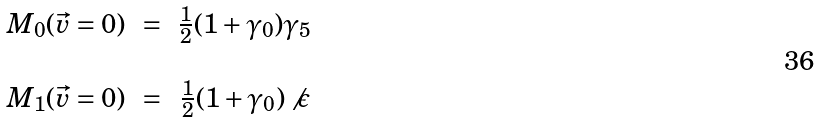<formula> <loc_0><loc_0><loc_500><loc_500>\begin{array} { c c c } M _ { 0 } ( \vec { v } = 0 ) & = & \frac { 1 } { 2 } ( 1 + \gamma _ { 0 } ) \gamma _ { 5 } \\ \\ M _ { 1 } ( \vec { v } = 0 ) & = & \frac { 1 } { 2 } ( 1 + \gamma _ { 0 } ) \not { \, \epsilon } \end{array}</formula> 